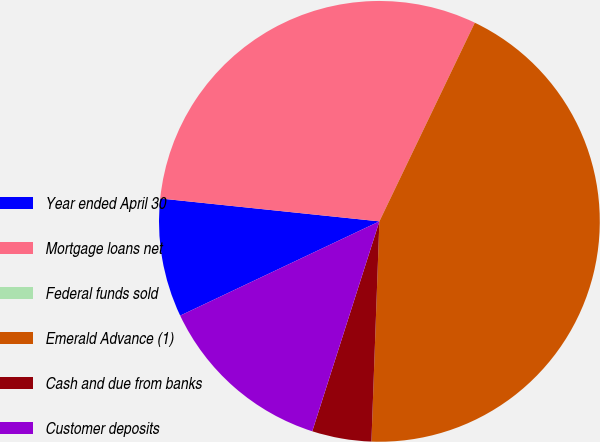<chart> <loc_0><loc_0><loc_500><loc_500><pie_chart><fcel>Year ended April 30<fcel>Mortgage loans net<fcel>Federal funds sold<fcel>Emerald Advance (1)<fcel>Cash and due from banks<fcel>Customer deposits<nl><fcel>8.69%<fcel>30.47%<fcel>0.0%<fcel>43.45%<fcel>4.35%<fcel>13.04%<nl></chart> 